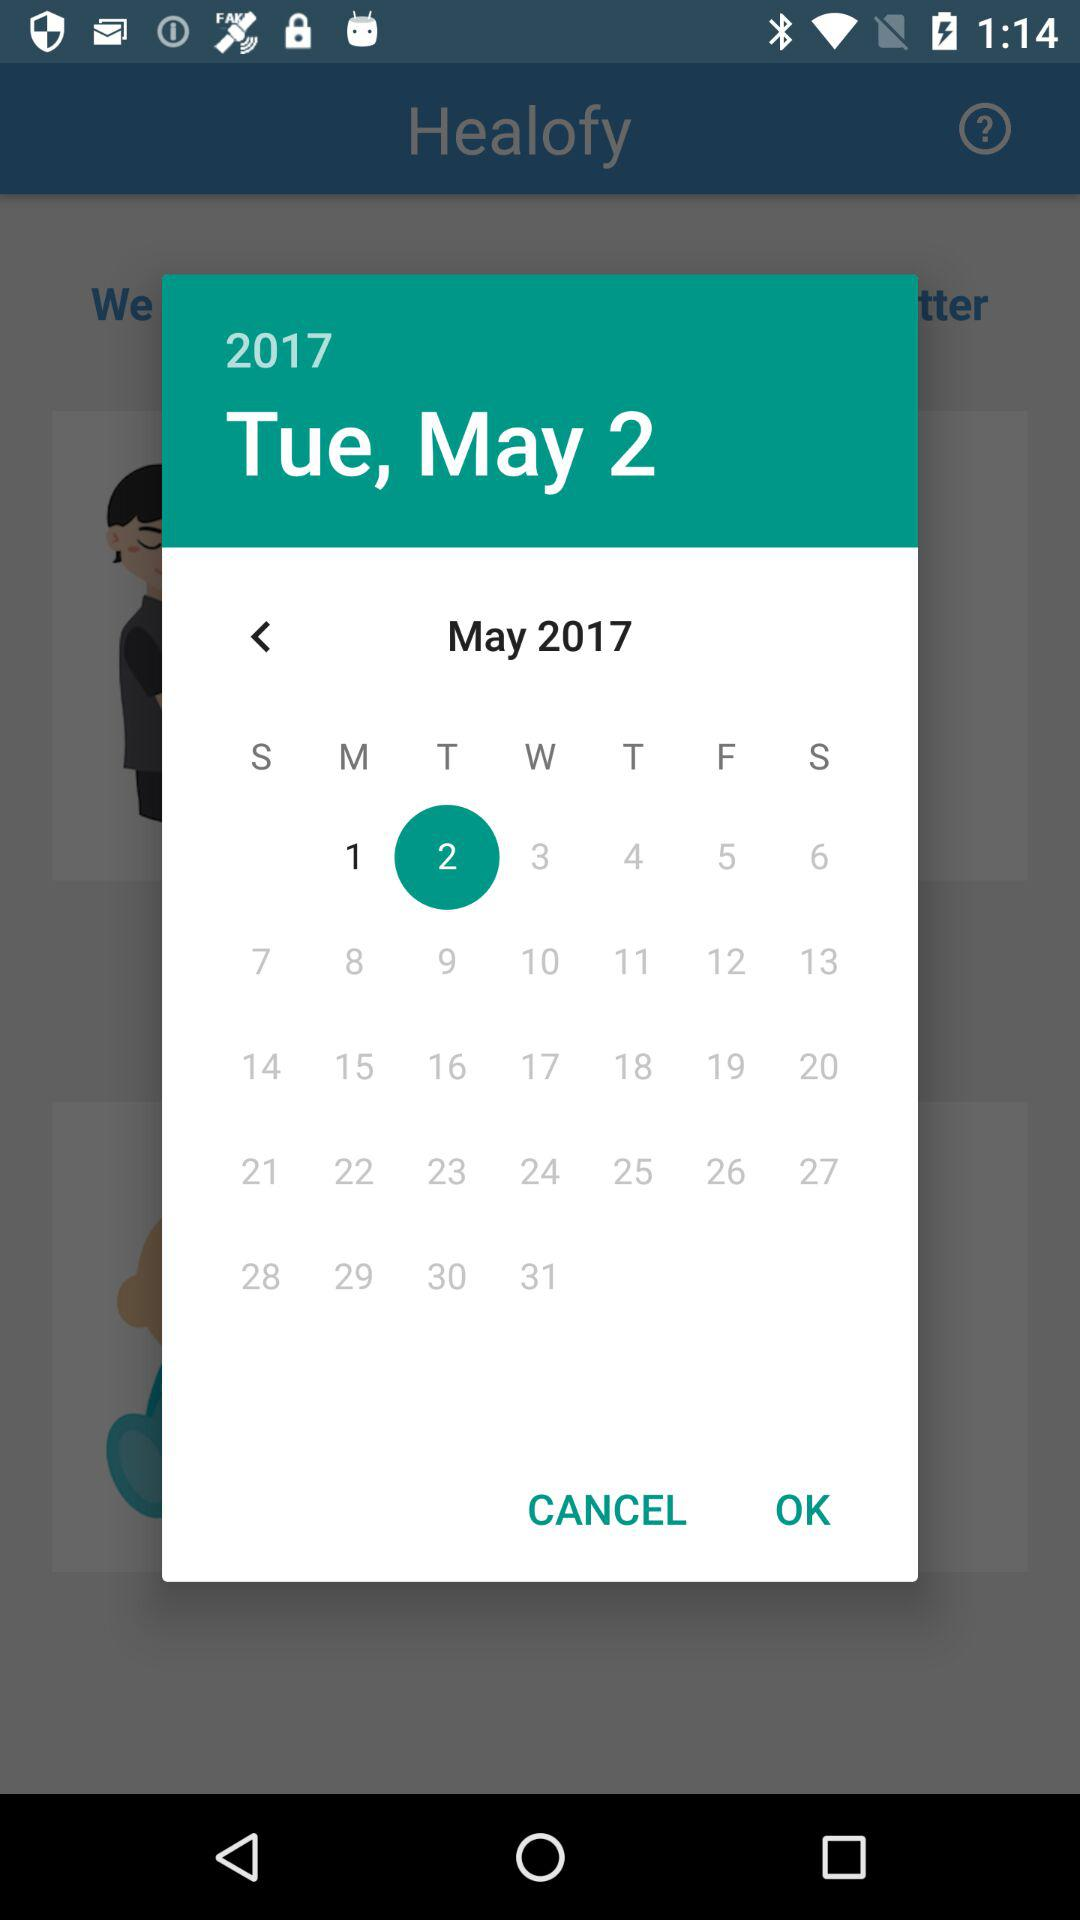What day is it on May 2? The day is Tuesday. 